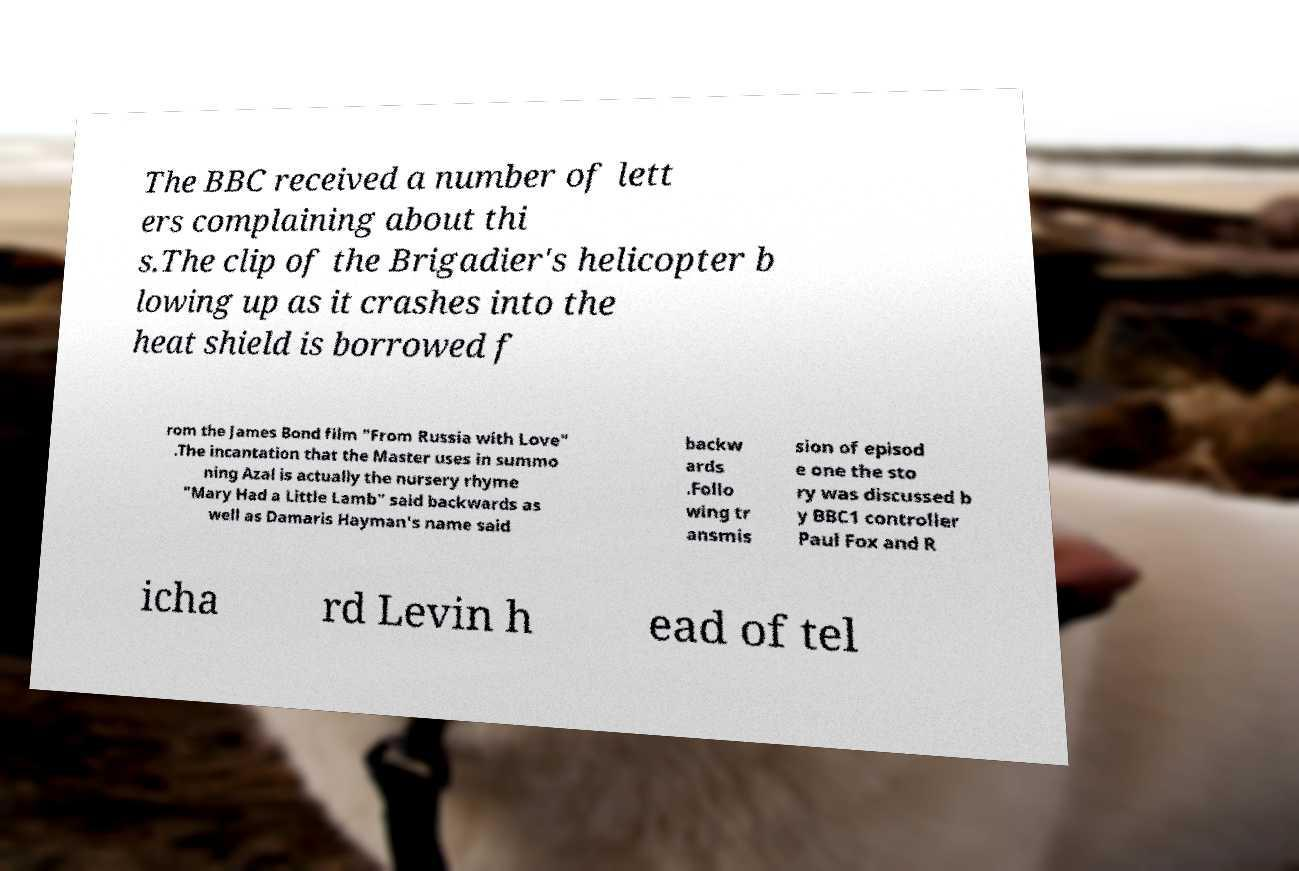For documentation purposes, I need the text within this image transcribed. Could you provide that? The BBC received a number of lett ers complaining about thi s.The clip of the Brigadier's helicopter b lowing up as it crashes into the heat shield is borrowed f rom the James Bond film "From Russia with Love" .The incantation that the Master uses in summo ning Azal is actually the nursery rhyme "Mary Had a Little Lamb" said backwards as well as Damaris Hayman's name said backw ards .Follo wing tr ansmis sion of episod e one the sto ry was discussed b y BBC1 controller Paul Fox and R icha rd Levin h ead of tel 